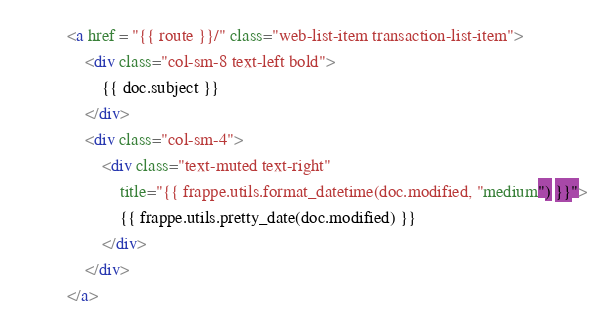<code> <loc_0><loc_0><loc_500><loc_500><_HTML_><a href = "{{ route }}/" class="web-list-item transaction-list-item">
	<div class="col-sm-8 text-left bold">
		{{ doc.subject }}
	</div>
	<div class="col-sm-4">
		<div class="text-muted text-right"
			title="{{ frappe.utils.format_datetime(doc.modified, "medium") }}">
			{{ frappe.utils.pretty_date(doc.modified) }}
		</div>
	</div>
</a>
</code> 